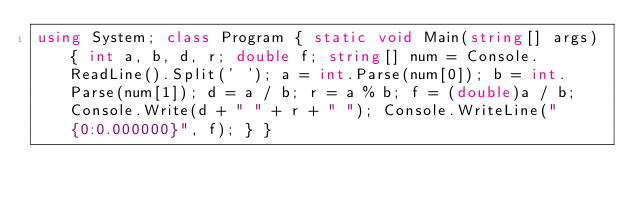<code> <loc_0><loc_0><loc_500><loc_500><_C#_>using System; class Program { static void Main(string[] args) { int a, b, d, r; double f; string[] num = Console.ReadLine().Split(' '); a = int.Parse(num[0]); b = int.Parse(num[1]); d = a / b; r = a % b; f = (double)a / b; Console.Write(d + " " + r + " "); Console.WriteLine("{0:0.000000}", f); } } 
</code> 